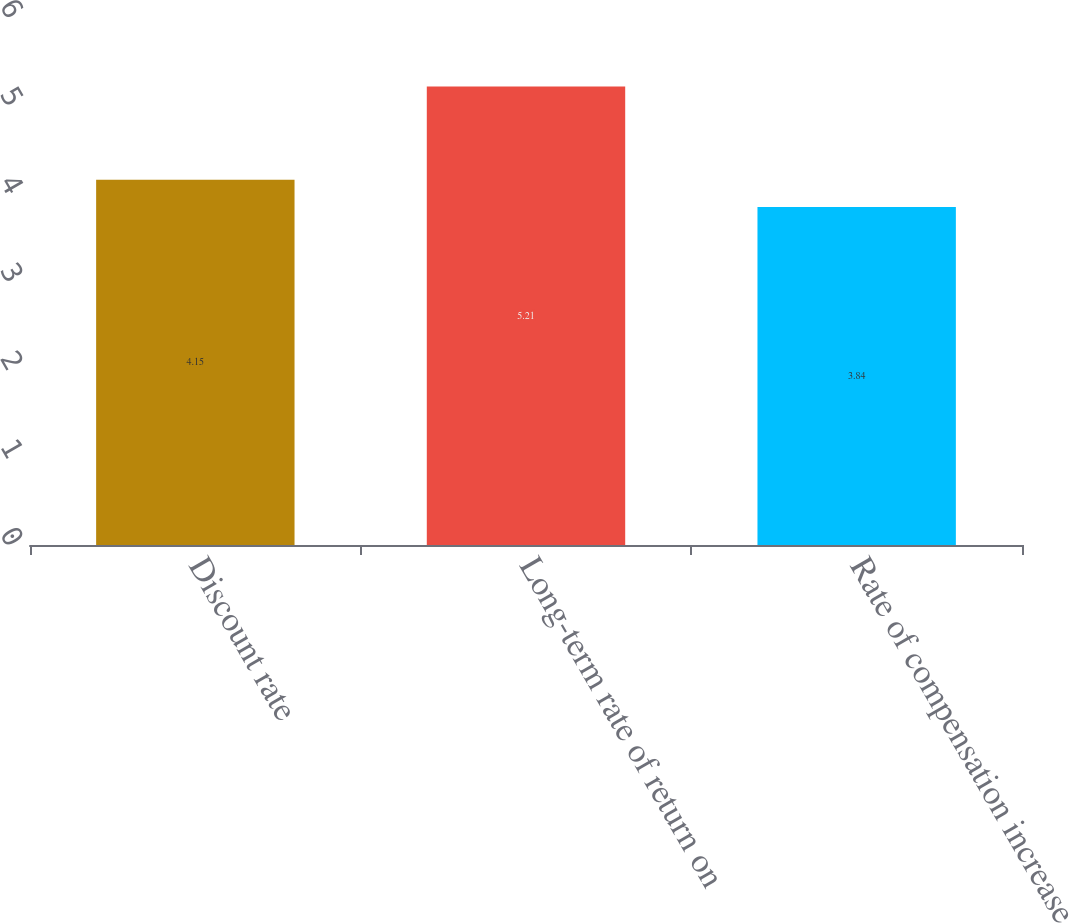Convert chart. <chart><loc_0><loc_0><loc_500><loc_500><bar_chart><fcel>Discount rate<fcel>Long-term rate of return on<fcel>Rate of compensation increase<nl><fcel>4.15<fcel>5.21<fcel>3.84<nl></chart> 